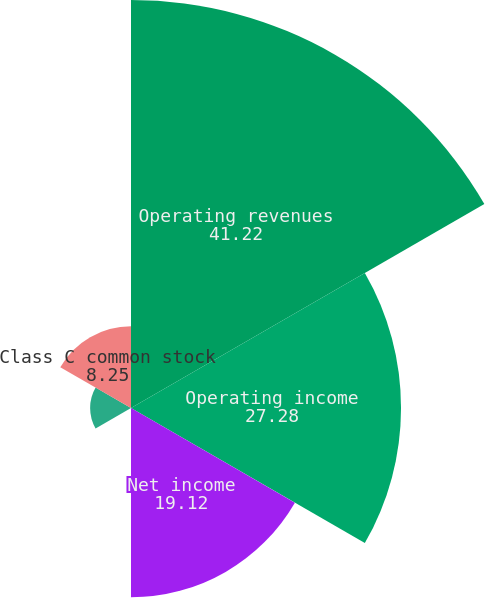Convert chart to OTSL. <chart><loc_0><loc_0><loc_500><loc_500><pie_chart><fcel>Operating revenues<fcel>Operating income<fcel>Net income<fcel>Class A common stock<fcel>Class B common stock<fcel>Class C common stock<nl><fcel>41.22%<fcel>27.28%<fcel>19.12%<fcel>0.01%<fcel>4.13%<fcel>8.25%<nl></chart> 